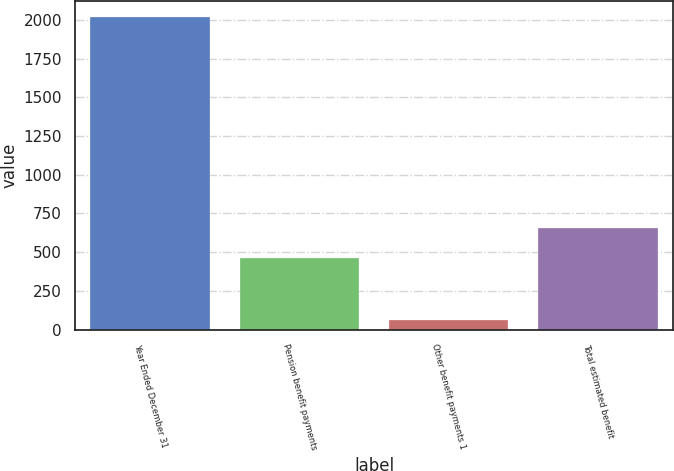<chart> <loc_0><loc_0><loc_500><loc_500><bar_chart><fcel>Year Ended December 31<fcel>Pension benefit payments<fcel>Other benefit payments 1<fcel>Total estimated benefit<nl><fcel>2021<fcel>460<fcel>59<fcel>656.2<nl></chart> 